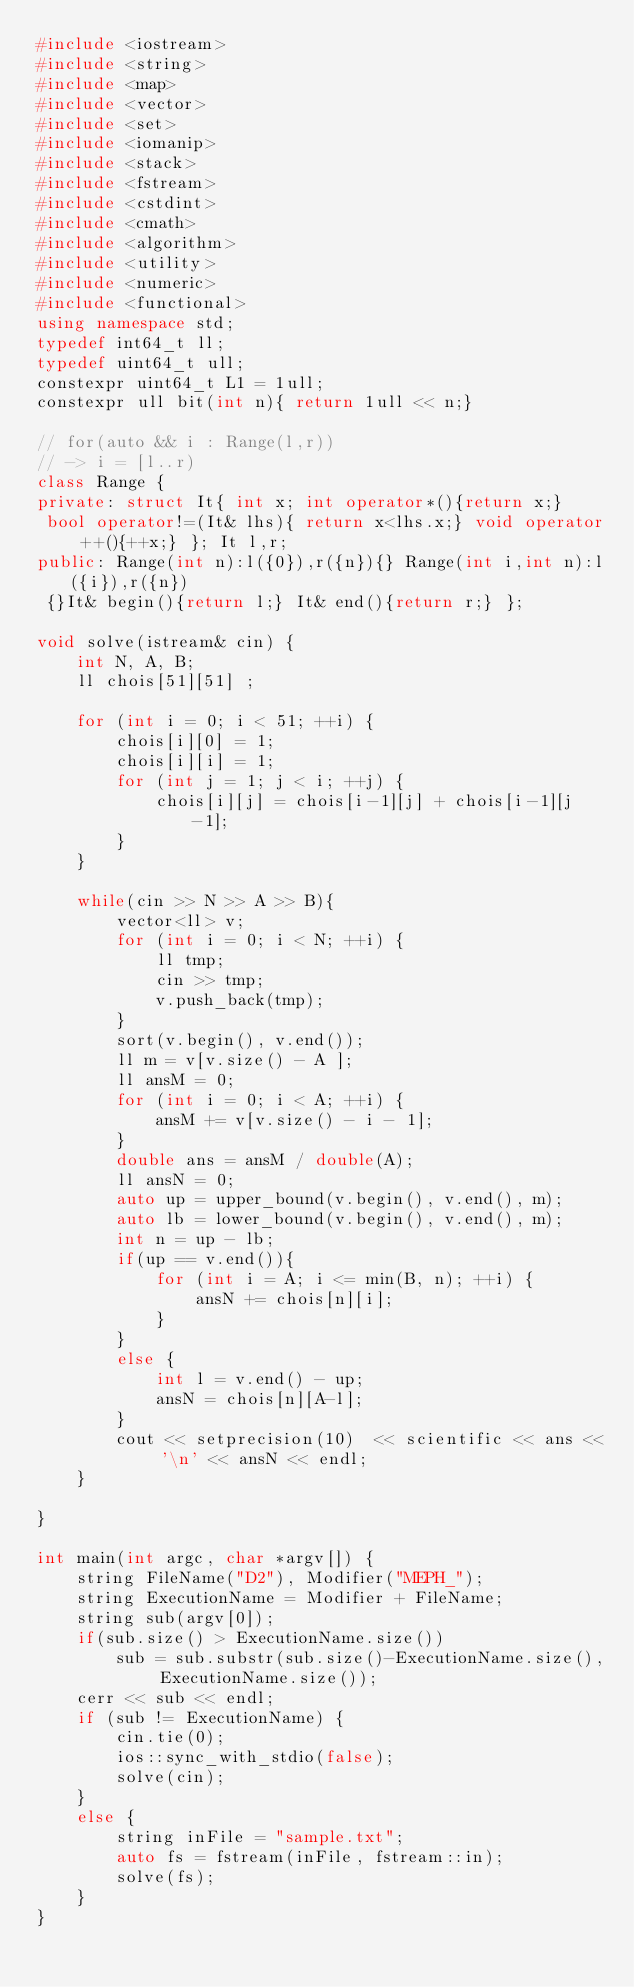Convert code to text. <code><loc_0><loc_0><loc_500><loc_500><_C++_>#include <iostream>
#include <string>
#include <map>
#include <vector>
#include <set>
#include <iomanip>
#include <stack>
#include <fstream>
#include <cstdint>
#include <cmath>
#include <algorithm>
#include <utility>
#include <numeric>
#include <functional>
using namespace std;
typedef int64_t ll;
typedef uint64_t ull;
constexpr uint64_t L1 = 1ull;
constexpr ull bit(int n){ return 1ull << n;}

// for(auto && i : Range(l,r))
// -> i = [l..r)
class Range {
private: struct It{ int x; int operator*(){return x;}
 bool operator!=(It& lhs){ return x<lhs.x;} void operator++(){++x;} }; It l,r;
public: Range(int n):l({0}),r({n}){} Range(int i,int n):l({i}),r({n})
 {}It& begin(){return l;} It& end(){return r;} };

void solve(istream& cin) {
    int N, A, B;
    ll chois[51][51] ;

    for (int i = 0; i < 51; ++i) {
        chois[i][0] = 1;
        chois[i][i] = 1;
        for (int j = 1; j < i; ++j) {
            chois[i][j] = chois[i-1][j] + chois[i-1][j-1];
        }
    }

    while(cin >> N >> A >> B){
        vector<ll> v;
        for (int i = 0; i < N; ++i) {
            ll tmp;
            cin >> tmp;
            v.push_back(tmp);
        }
        sort(v.begin(), v.end());
        ll m = v[v.size() - A ];
        ll ansM = 0;
        for (int i = 0; i < A; ++i) {
            ansM += v[v.size() - i - 1];
        }
        double ans = ansM / double(A);
        ll ansN = 0;
        auto up = upper_bound(v.begin(), v.end(), m);
        auto lb = lower_bound(v.begin(), v.end(), m);
        int n = up - lb;
        if(up == v.end()){
            for (int i = A; i <= min(B, n); ++i) {
                ansN += chois[n][i];
            }
        }
        else {
            int l = v.end() - up;
            ansN = chois[n][A-l];
        }
        cout << setprecision(10)  << scientific << ans << '\n' << ansN << endl;
    }

}

int main(int argc, char *argv[]) {
    string FileName("D2"), Modifier("MEPH_");
    string ExecutionName = Modifier + FileName;
    string sub(argv[0]);
    if(sub.size() > ExecutionName.size())
        sub = sub.substr(sub.size()-ExecutionName.size(), ExecutionName.size());
    cerr << sub << endl;
    if (sub != ExecutionName) {
        cin.tie(0);
        ios::sync_with_stdio(false);
        solve(cin);
    }
    else {
        string inFile = "sample.txt";
        auto fs = fstream(inFile, fstream::in);
        solve(fs);
    }
}</code> 